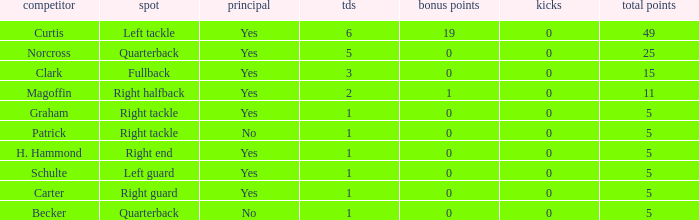Name the least touchdowns for 11 points 2.0. 